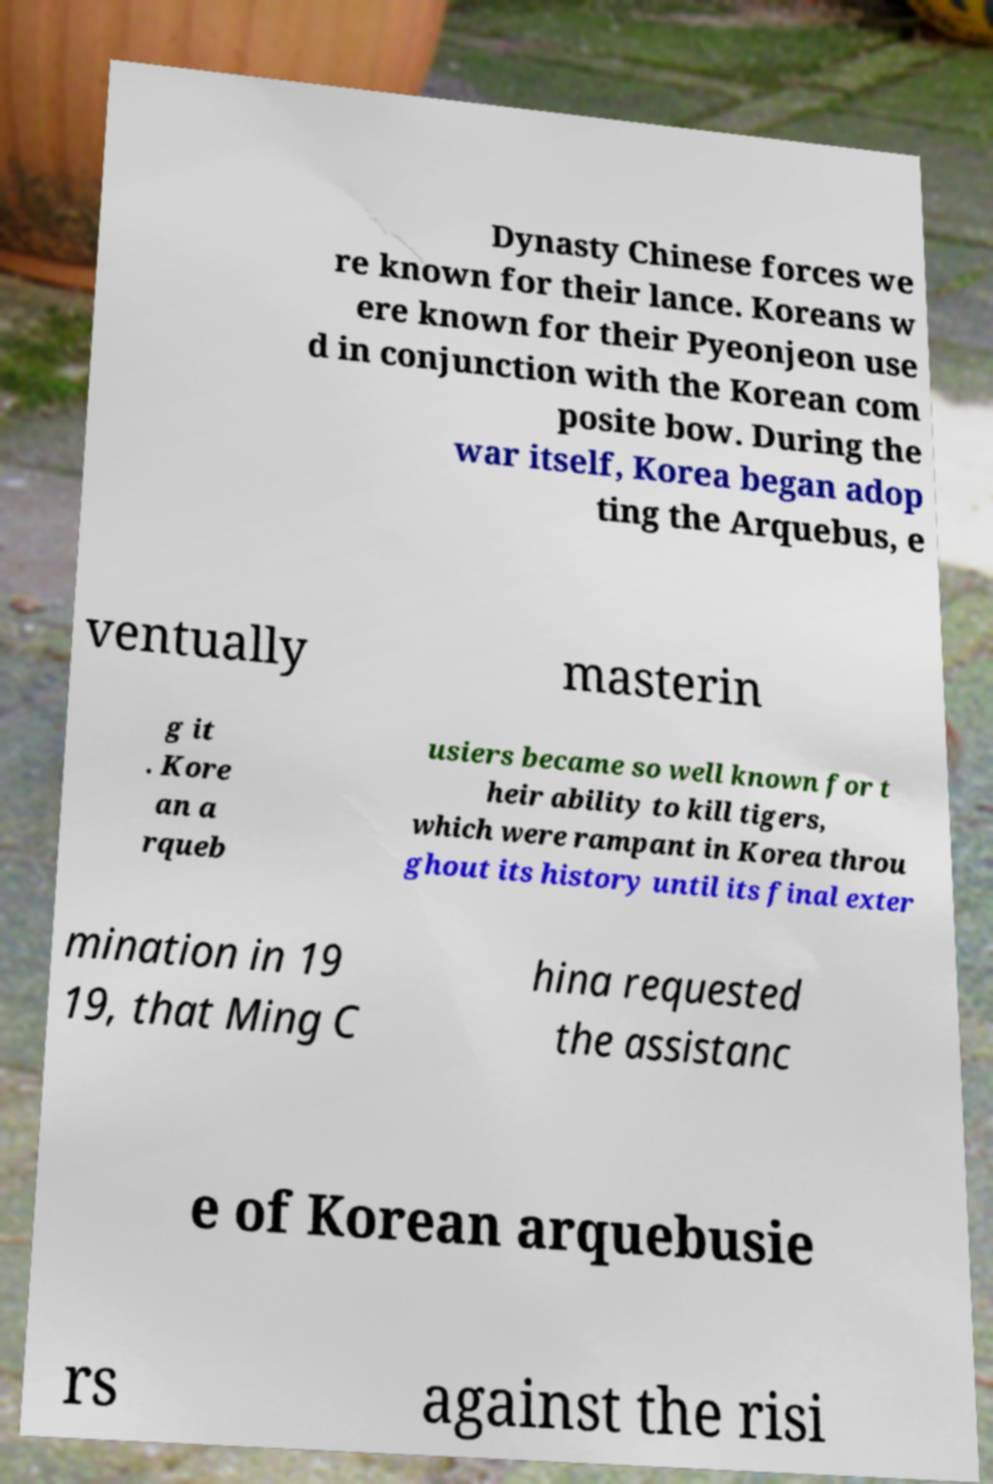I need the written content from this picture converted into text. Can you do that? Dynasty Chinese forces we re known for their lance. Koreans w ere known for their Pyeonjeon use d in conjunction with the Korean com posite bow. During the war itself, Korea began adop ting the Arquebus, e ventually masterin g it . Kore an a rqueb usiers became so well known for t heir ability to kill tigers, which were rampant in Korea throu ghout its history until its final exter mination in 19 19, that Ming C hina requested the assistanc e of Korean arquebusie rs against the risi 